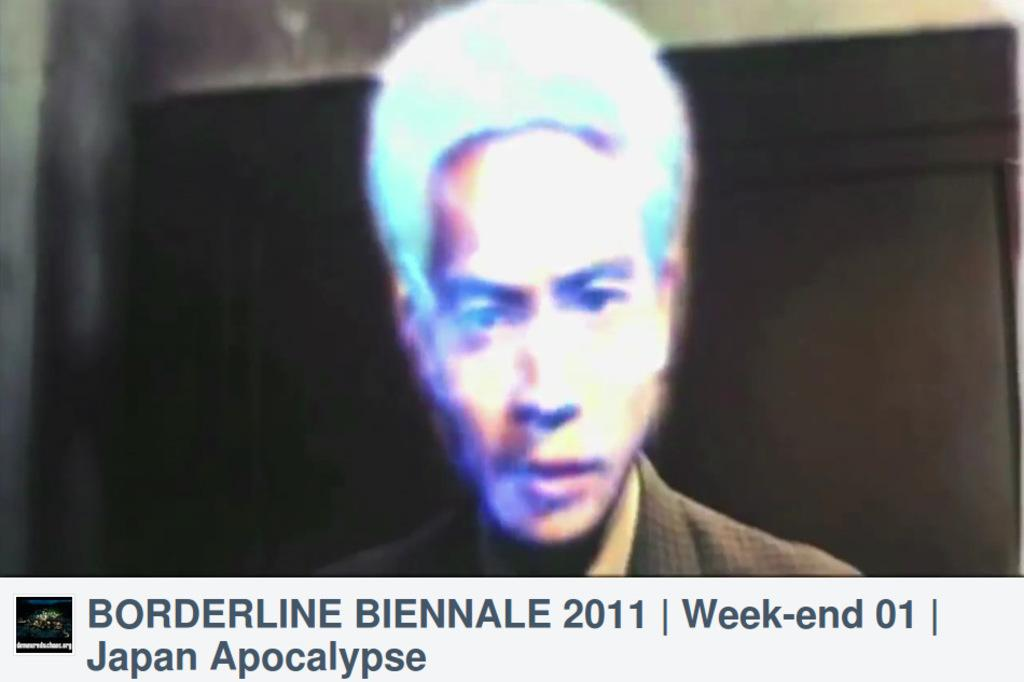What elements are present in the image? There are pictures, text, a man, a wall, text below the picture, and a logo beside the text. Can you describe the man in the picture? There is a man in the picture, but no specific details about his appearance are provided. What is the relationship between the picture and the text below it? The text below the picture provides additional information or context about the picture. What is the logo beside the text? The logo is a symbol or design that represents a brand or organization. Can you tell me how many rats are playing chess in the image? There are no rats or chess game present in the image. What type of sorting algorithm is being used in the image? There is no reference to a sorting algorithm or any sorting activity in the image. 